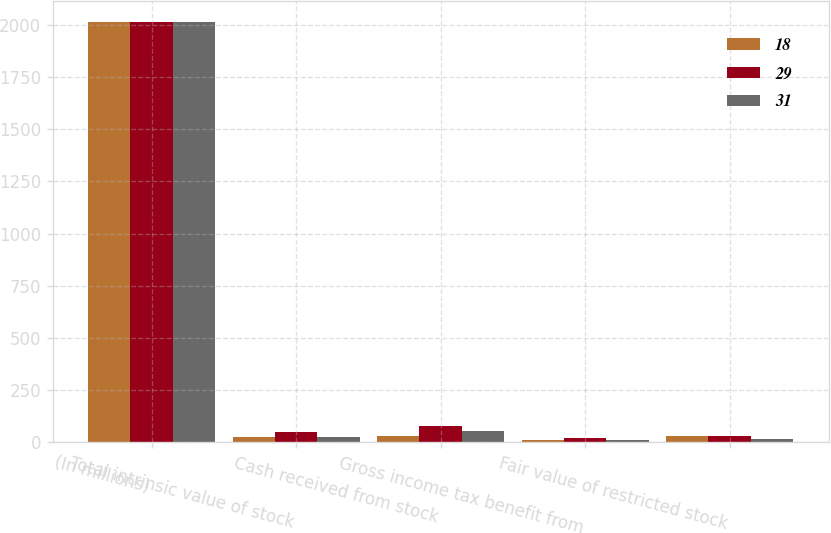Convert chart to OTSL. <chart><loc_0><loc_0><loc_500><loc_500><stacked_bar_chart><ecel><fcel>(In millions)<fcel>Total intrinsic value of stock<fcel>Cash received from stock<fcel>Gross income tax benefit from<fcel>Fair value of restricted stock<nl><fcel>18<fcel>2013<fcel>27<fcel>32<fcel>10<fcel>31<nl><fcel>29<fcel>2012<fcel>51<fcel>80<fcel>20<fcel>29<nl><fcel>31<fcel>2011<fcel>26<fcel>54<fcel>10<fcel>18<nl></chart> 